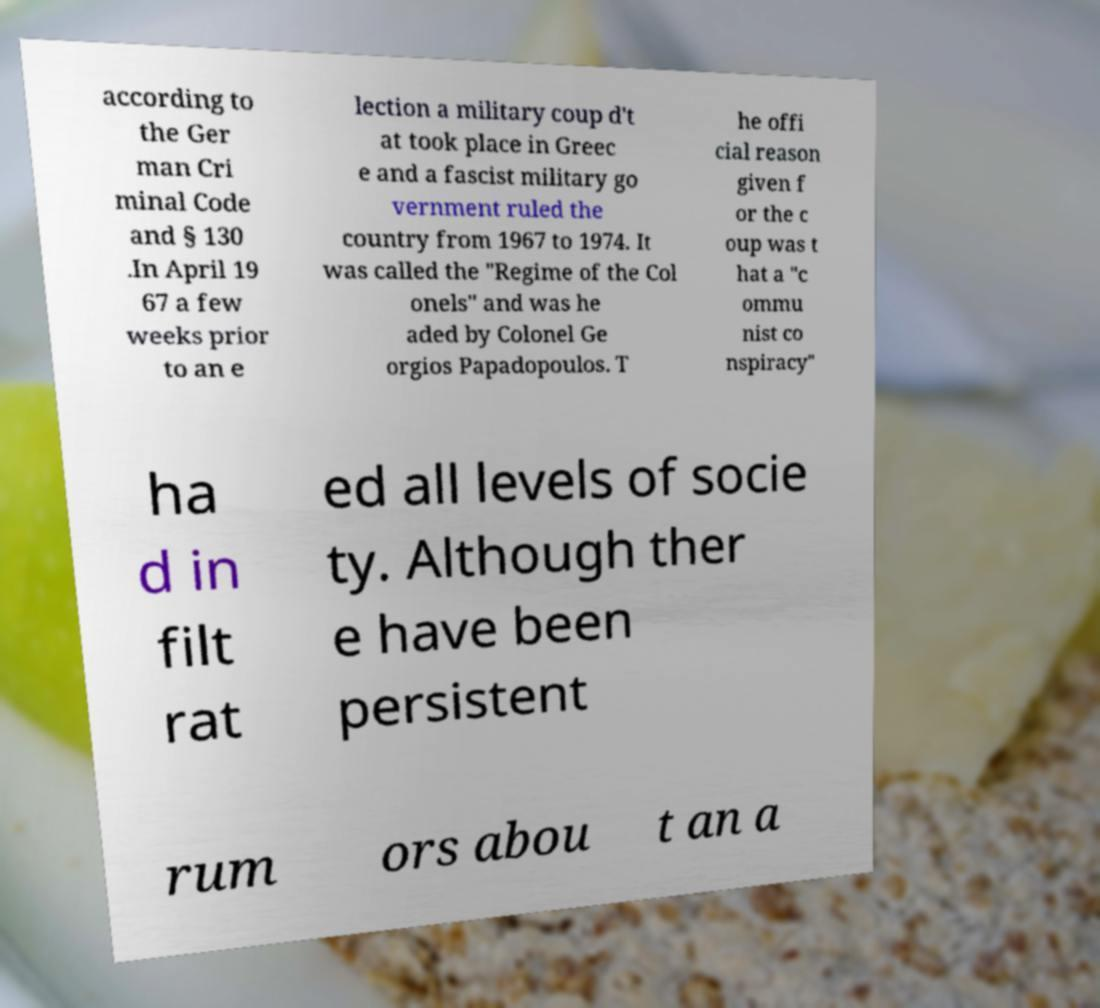For documentation purposes, I need the text within this image transcribed. Could you provide that? according to the Ger man Cri minal Code and § 130 .In April 19 67 a few weeks prior to an e lection a military coup d't at took place in Greec e and a fascist military go vernment ruled the country from 1967 to 1974. It was called the "Regime of the Col onels" and was he aded by Colonel Ge orgios Papadopoulos. T he offi cial reason given f or the c oup was t hat a "c ommu nist co nspiracy" ha d in filt rat ed all levels of socie ty. Although ther e have been persistent rum ors abou t an a 